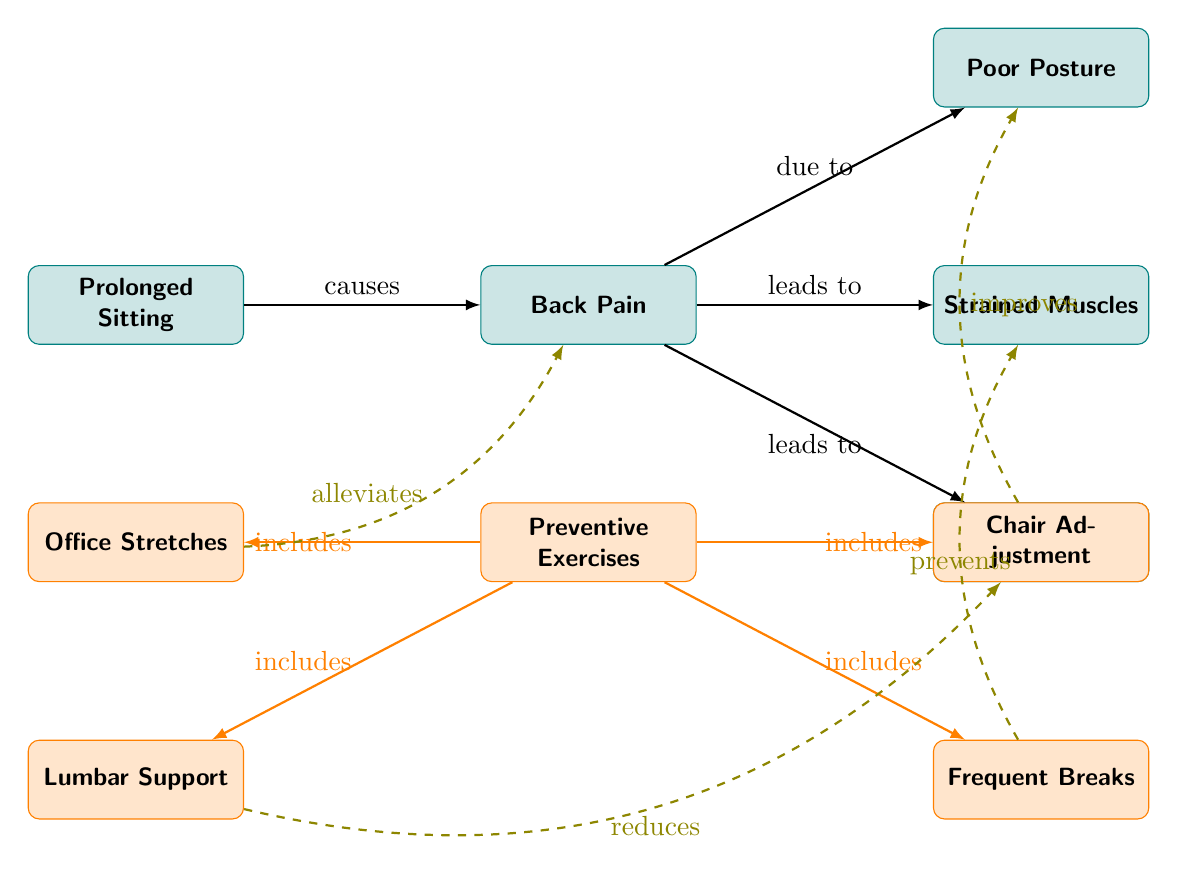What is the main cause of back pain in the diagram? The diagram indicates that "Prolonged Sitting" is the primary cause that leads to "Back Pain." This relationship is shown with an arrow labeled "causes" pointing from "Prolonged Sitting" to "Back Pain."
Answer: Prolonged Sitting What is one of the outcomes of back pain depicted in the diagram? The diagram shows that "Back Pain" can lead to two outcomes: "Strained Muscles" and "Compression of Spine." These connections are illustrated with arrows labeled "leads to," indicating that back pain results in these issues.
Answer: Strained Muscles How many preventive exercises are listed in the diagram? The diagram enumerates four preventive exercises that are categorized under "Preventive Exercises." There are distinct nodes labeled "Office Stretches," "Chair Adjustment," "Lumbar Support," and "Frequent Breaks," all connected to the central node "Preventive Exercises."
Answer: Four Which preventive exercise improves poor posture? According to the diagram, "Chair Adjustment" is the preventive exercise that "improves" "Poor Posture." This is shown with a dashed arrow pointing from "Chair Adjustment" to "Poor Posture," indicating a positive influence in the relationship.
Answer: Chair Adjustment What does "Frequent Breaks" do in relation to strained muscles? The diagram illustrates that "Frequent Breaks" "prevents" "Strained Muscles." This is indicated by a dashed arrow from "Frequent Breaks" to "Strained Muscles," showing a preventive effect.
Answer: Prevents Which condition is indicated as having a direct relationship with both poor posture and back pain? The diagram demonstrates that "Back Pain" is directly connected to "Poor Posture" with a "due to" label. Since "Back Pain" influences both "Strained Muscles" and "Compression of Spine," it represents the central condition influenced by poor posture as well.
Answer: Back Pain Which node represents a significant risk factor leading to back pain? "Poor Posture" is the node depicted in the diagram as a significant risk factor leading to "Back Pain." It is connected with a dashed line that indicates a contributory relationship.
Answer: Poor Posture 